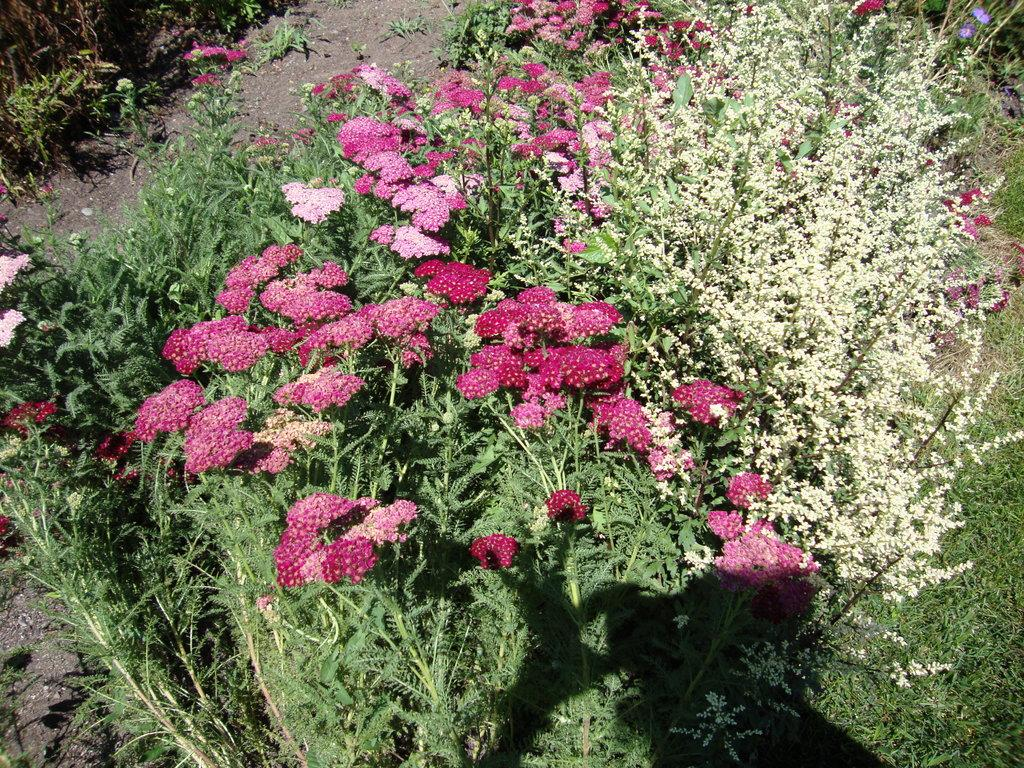What color are the flowers in the image? The flowers in the image are pink. What type of plant do the flowers belong to? The flowers belong to a plant. Are there any other plants visible in the image? Yes, there are other plants visible in the image. How many tickets can be seen hanging from the plant in the image? There are no tickets present in the image; it features pink flowers and other plants. What type of vegetable is growing alongside the flowers in the image? There is no vegetable, such as celery, growing alongside the flowers in the image. 